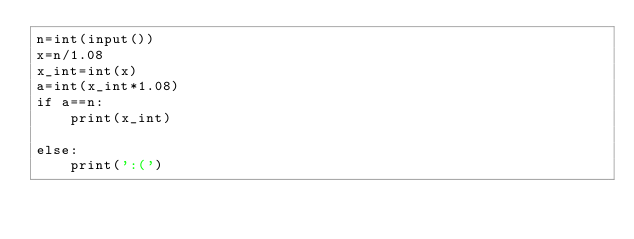<code> <loc_0><loc_0><loc_500><loc_500><_Python_>n=int(input())
x=n/1.08
x_int=int(x)
a=int(x_int*1.08)
if a==n:
    print(x_int)

else:
    print(':(')

</code> 